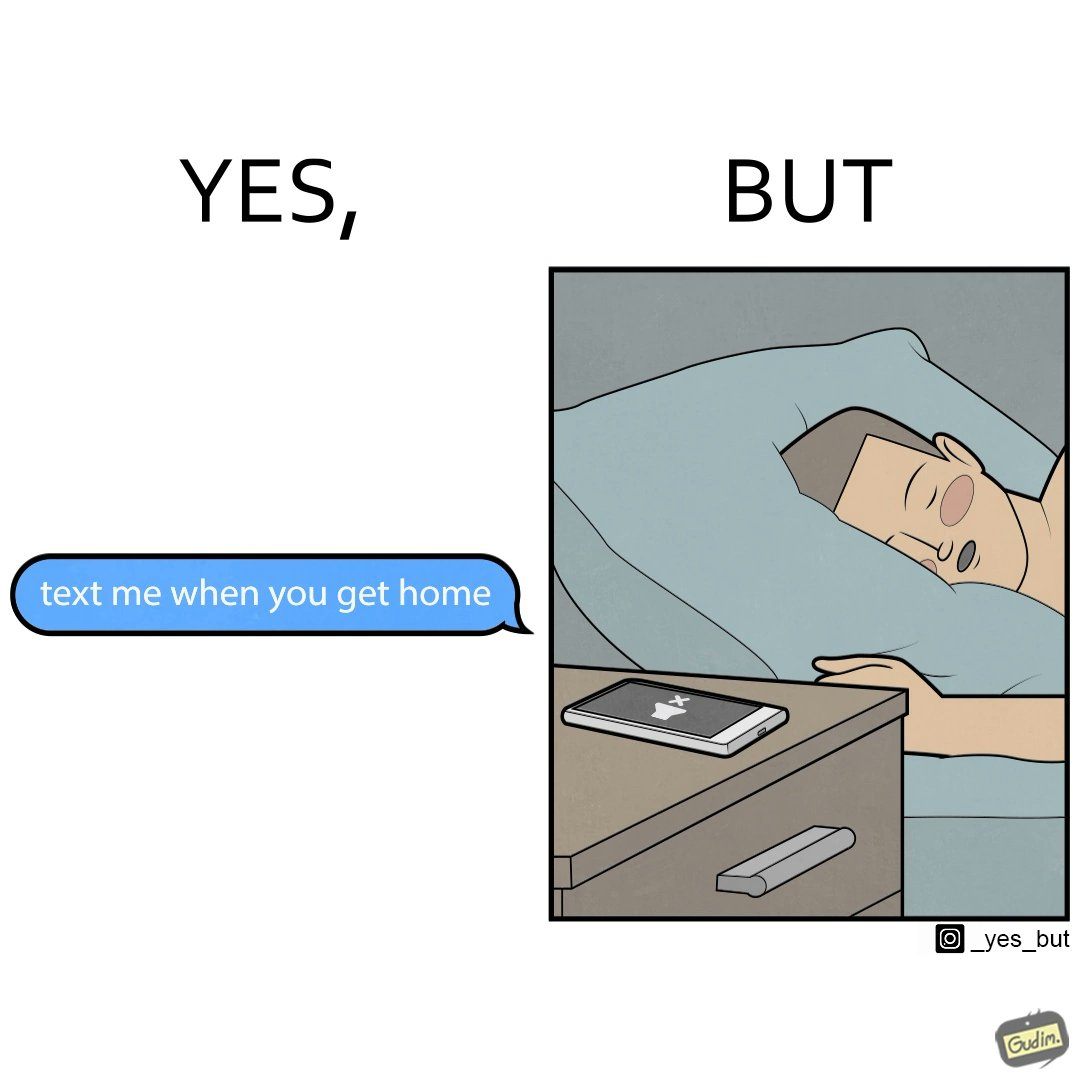What do you see in each half of this image? In the left part of the image: It is a text message asking the recipient to reply back once he/she returns home In the right part of the image: It is a man sleeping on his bed with his phone on silent mode 